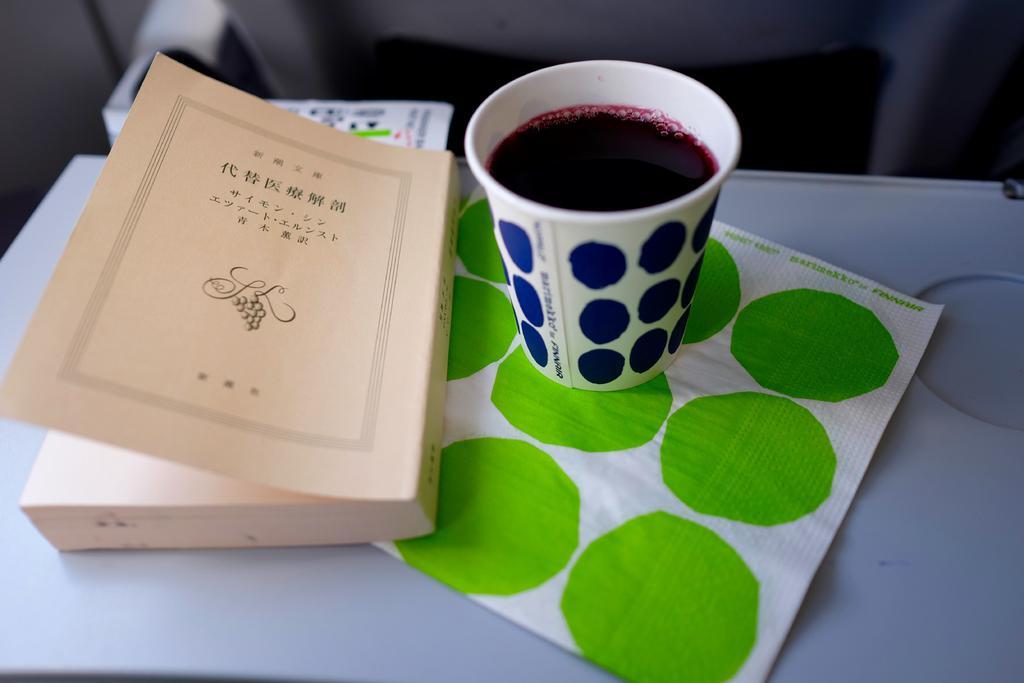In one or two sentences, can you explain what this image depicts? In the image we can see a book, glass and in the glass there is a liquid, tissue paper and white surface and the background is blurred. 